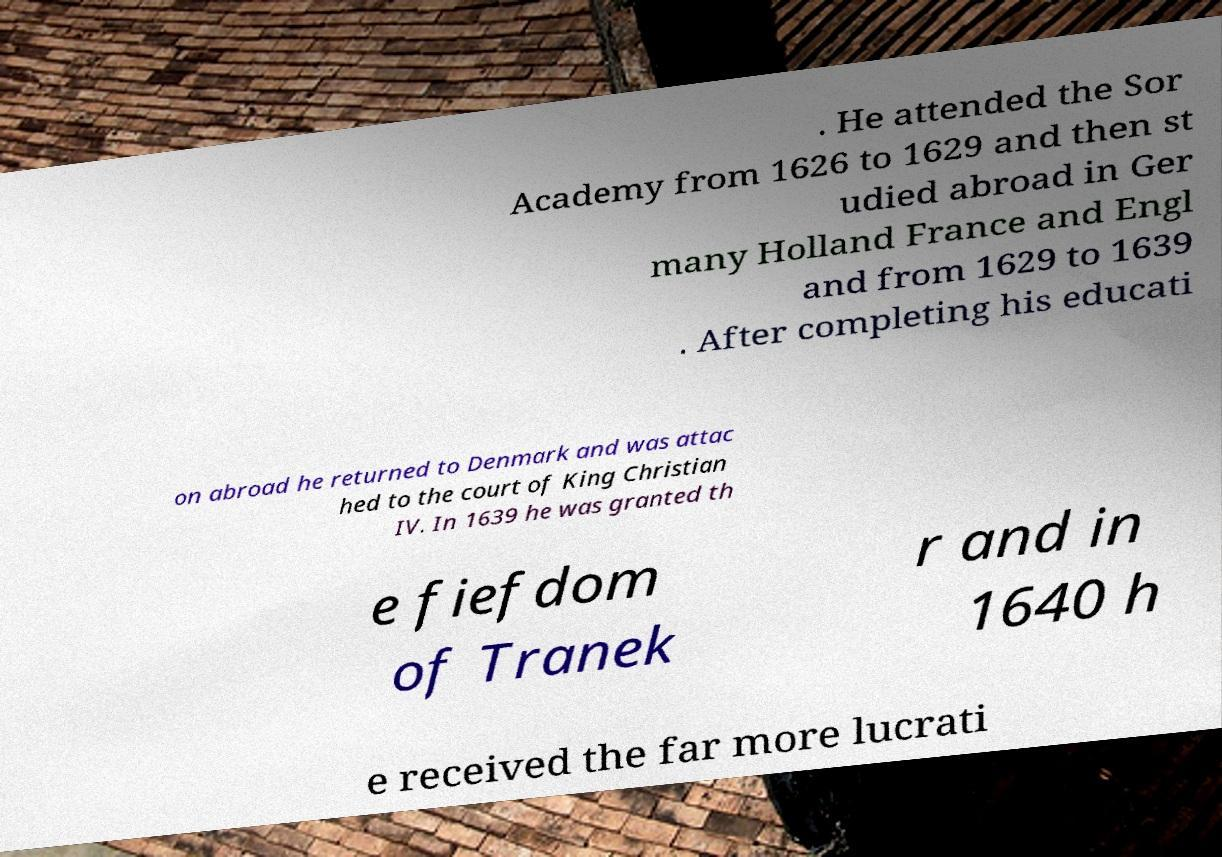Can you accurately transcribe the text from the provided image for me? . He attended the Sor Academy from 1626 to 1629 and then st udied abroad in Ger many Holland France and Engl and from 1629 to 1639 . After completing his educati on abroad he returned to Denmark and was attac hed to the court of King Christian IV. In 1639 he was granted th e fiefdom of Tranek r and in 1640 h e received the far more lucrati 